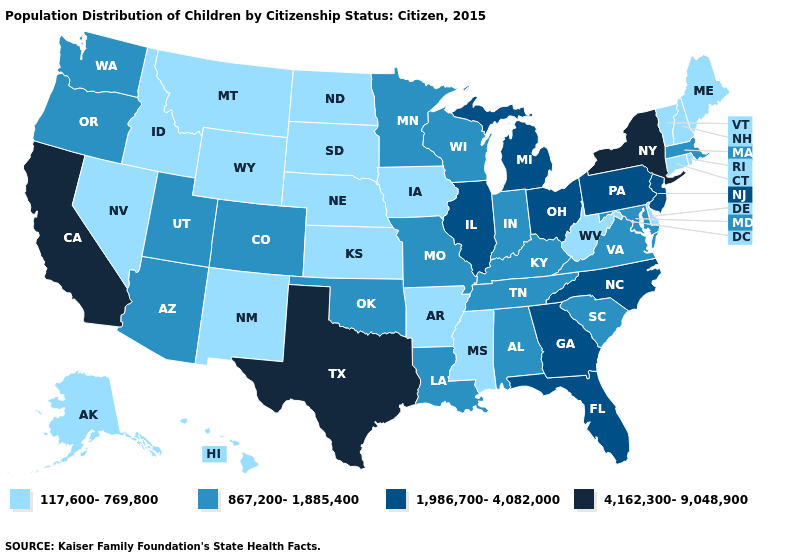Among the states that border West Virginia , which have the highest value?
Keep it brief. Ohio, Pennsylvania. What is the value of Virginia?
Short answer required. 867,200-1,885,400. Which states have the lowest value in the South?
Be succinct. Arkansas, Delaware, Mississippi, West Virginia. What is the highest value in the West ?
Concise answer only. 4,162,300-9,048,900. What is the value of West Virginia?
Answer briefly. 117,600-769,800. What is the value of South Dakota?
Quick response, please. 117,600-769,800. Does Georgia have the same value as North Carolina?
Concise answer only. Yes. What is the highest value in the MidWest ?
Answer briefly. 1,986,700-4,082,000. Name the states that have a value in the range 117,600-769,800?
Concise answer only. Alaska, Arkansas, Connecticut, Delaware, Hawaii, Idaho, Iowa, Kansas, Maine, Mississippi, Montana, Nebraska, Nevada, New Hampshire, New Mexico, North Dakota, Rhode Island, South Dakota, Vermont, West Virginia, Wyoming. Among the states that border Virginia , does West Virginia have the lowest value?
Be succinct. Yes. Name the states that have a value in the range 867,200-1,885,400?
Short answer required. Alabama, Arizona, Colorado, Indiana, Kentucky, Louisiana, Maryland, Massachusetts, Minnesota, Missouri, Oklahoma, Oregon, South Carolina, Tennessee, Utah, Virginia, Washington, Wisconsin. Does Arizona have the same value as Ohio?
Answer briefly. No. What is the highest value in the USA?
Short answer required. 4,162,300-9,048,900. What is the value of Arizona?
Quick response, please. 867,200-1,885,400. What is the value of Delaware?
Keep it brief. 117,600-769,800. 